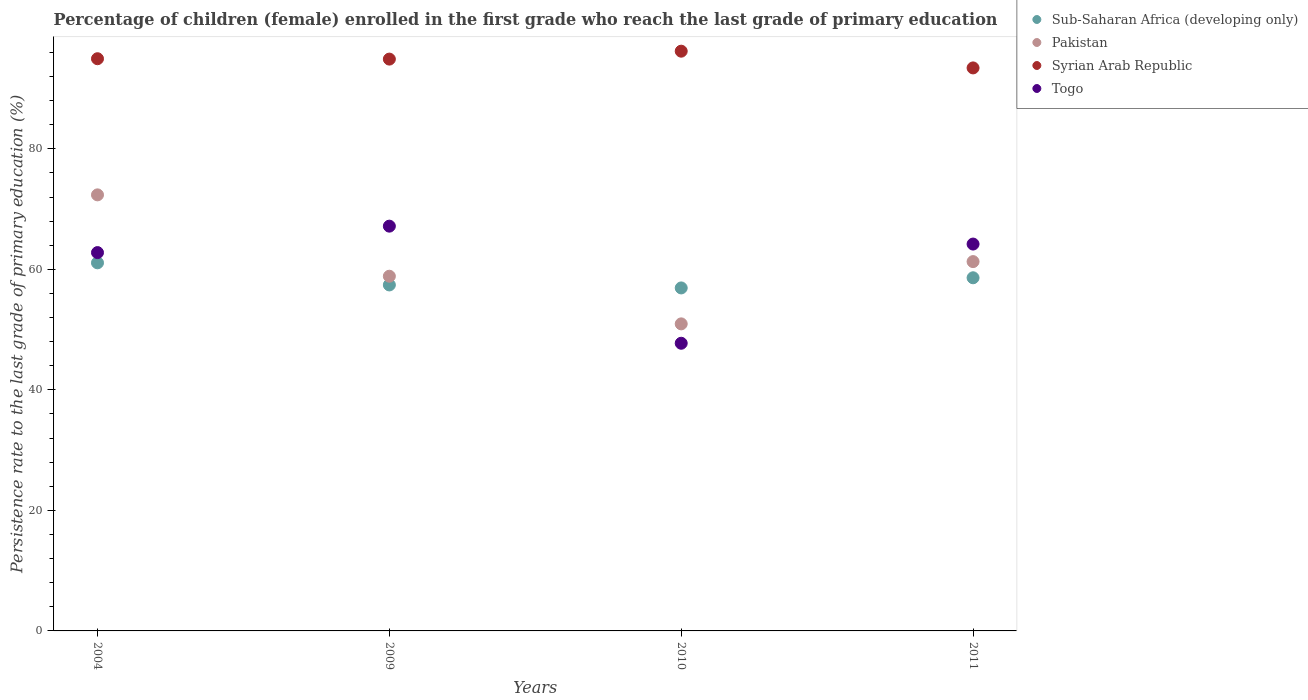How many different coloured dotlines are there?
Ensure brevity in your answer.  4. What is the persistence rate of children in Togo in 2004?
Make the answer very short. 62.78. Across all years, what is the maximum persistence rate of children in Sub-Saharan Africa (developing only)?
Your answer should be very brief. 61.08. Across all years, what is the minimum persistence rate of children in Togo?
Your response must be concise. 47.74. What is the total persistence rate of children in Sub-Saharan Africa (developing only) in the graph?
Provide a short and direct response. 234.02. What is the difference between the persistence rate of children in Syrian Arab Republic in 2009 and that in 2010?
Your answer should be very brief. -1.32. What is the difference between the persistence rate of children in Togo in 2011 and the persistence rate of children in Syrian Arab Republic in 2010?
Your answer should be compact. -32.01. What is the average persistence rate of children in Pakistan per year?
Your answer should be very brief. 60.87. In the year 2004, what is the difference between the persistence rate of children in Pakistan and persistence rate of children in Sub-Saharan Africa (developing only)?
Make the answer very short. 11.28. In how many years, is the persistence rate of children in Sub-Saharan Africa (developing only) greater than 32 %?
Provide a short and direct response. 4. What is the ratio of the persistence rate of children in Syrian Arab Republic in 2004 to that in 2009?
Offer a very short reply. 1. Is the difference between the persistence rate of children in Pakistan in 2004 and 2010 greater than the difference between the persistence rate of children in Sub-Saharan Africa (developing only) in 2004 and 2010?
Provide a succinct answer. Yes. What is the difference between the highest and the second highest persistence rate of children in Sub-Saharan Africa (developing only)?
Offer a very short reply. 2.48. What is the difference between the highest and the lowest persistence rate of children in Pakistan?
Make the answer very short. 21.41. In how many years, is the persistence rate of children in Sub-Saharan Africa (developing only) greater than the average persistence rate of children in Sub-Saharan Africa (developing only) taken over all years?
Offer a very short reply. 2. Is it the case that in every year, the sum of the persistence rate of children in Syrian Arab Republic and persistence rate of children in Togo  is greater than the persistence rate of children in Pakistan?
Give a very brief answer. Yes. Is the persistence rate of children in Togo strictly less than the persistence rate of children in Pakistan over the years?
Your answer should be very brief. No. Are the values on the major ticks of Y-axis written in scientific E-notation?
Ensure brevity in your answer.  No. How many legend labels are there?
Provide a succinct answer. 4. How are the legend labels stacked?
Provide a short and direct response. Vertical. What is the title of the graph?
Provide a short and direct response. Percentage of children (female) enrolled in the first grade who reach the last grade of primary education. Does "Qatar" appear as one of the legend labels in the graph?
Provide a short and direct response. No. What is the label or title of the Y-axis?
Ensure brevity in your answer.  Persistence rate to the last grade of primary education (%). What is the Persistence rate to the last grade of primary education (%) of Sub-Saharan Africa (developing only) in 2004?
Ensure brevity in your answer.  61.08. What is the Persistence rate to the last grade of primary education (%) in Pakistan in 2004?
Provide a short and direct response. 72.36. What is the Persistence rate to the last grade of primary education (%) of Syrian Arab Republic in 2004?
Your answer should be compact. 94.96. What is the Persistence rate to the last grade of primary education (%) of Togo in 2004?
Your response must be concise. 62.78. What is the Persistence rate to the last grade of primary education (%) of Sub-Saharan Africa (developing only) in 2009?
Keep it short and to the point. 57.41. What is the Persistence rate to the last grade of primary education (%) in Pakistan in 2009?
Keep it short and to the point. 58.86. What is the Persistence rate to the last grade of primary education (%) of Syrian Arab Republic in 2009?
Make the answer very short. 94.89. What is the Persistence rate to the last grade of primary education (%) in Togo in 2009?
Ensure brevity in your answer.  67.17. What is the Persistence rate to the last grade of primary education (%) in Sub-Saharan Africa (developing only) in 2010?
Offer a terse response. 56.92. What is the Persistence rate to the last grade of primary education (%) of Pakistan in 2010?
Give a very brief answer. 50.95. What is the Persistence rate to the last grade of primary education (%) in Syrian Arab Republic in 2010?
Your answer should be compact. 96.21. What is the Persistence rate to the last grade of primary education (%) in Togo in 2010?
Your response must be concise. 47.74. What is the Persistence rate to the last grade of primary education (%) in Sub-Saharan Africa (developing only) in 2011?
Provide a short and direct response. 58.6. What is the Persistence rate to the last grade of primary education (%) in Pakistan in 2011?
Offer a very short reply. 61.29. What is the Persistence rate to the last grade of primary education (%) in Syrian Arab Republic in 2011?
Your response must be concise. 93.43. What is the Persistence rate to the last grade of primary education (%) of Togo in 2011?
Provide a short and direct response. 64.2. Across all years, what is the maximum Persistence rate to the last grade of primary education (%) of Sub-Saharan Africa (developing only)?
Ensure brevity in your answer.  61.08. Across all years, what is the maximum Persistence rate to the last grade of primary education (%) in Pakistan?
Offer a terse response. 72.36. Across all years, what is the maximum Persistence rate to the last grade of primary education (%) in Syrian Arab Republic?
Provide a succinct answer. 96.21. Across all years, what is the maximum Persistence rate to the last grade of primary education (%) of Togo?
Give a very brief answer. 67.17. Across all years, what is the minimum Persistence rate to the last grade of primary education (%) of Sub-Saharan Africa (developing only)?
Offer a terse response. 56.92. Across all years, what is the minimum Persistence rate to the last grade of primary education (%) of Pakistan?
Offer a very short reply. 50.95. Across all years, what is the minimum Persistence rate to the last grade of primary education (%) of Syrian Arab Republic?
Make the answer very short. 93.43. Across all years, what is the minimum Persistence rate to the last grade of primary education (%) in Togo?
Your answer should be very brief. 47.74. What is the total Persistence rate to the last grade of primary education (%) of Sub-Saharan Africa (developing only) in the graph?
Provide a short and direct response. 234.02. What is the total Persistence rate to the last grade of primary education (%) of Pakistan in the graph?
Offer a very short reply. 243.47. What is the total Persistence rate to the last grade of primary education (%) of Syrian Arab Republic in the graph?
Your answer should be very brief. 379.48. What is the total Persistence rate to the last grade of primary education (%) of Togo in the graph?
Keep it short and to the point. 241.89. What is the difference between the Persistence rate to the last grade of primary education (%) in Sub-Saharan Africa (developing only) in 2004 and that in 2009?
Offer a very short reply. 3.67. What is the difference between the Persistence rate to the last grade of primary education (%) in Pakistan in 2004 and that in 2009?
Give a very brief answer. 13.5. What is the difference between the Persistence rate to the last grade of primary education (%) in Syrian Arab Republic in 2004 and that in 2009?
Ensure brevity in your answer.  0.06. What is the difference between the Persistence rate to the last grade of primary education (%) of Togo in 2004 and that in 2009?
Ensure brevity in your answer.  -4.39. What is the difference between the Persistence rate to the last grade of primary education (%) in Sub-Saharan Africa (developing only) in 2004 and that in 2010?
Your answer should be very brief. 4.17. What is the difference between the Persistence rate to the last grade of primary education (%) of Pakistan in 2004 and that in 2010?
Keep it short and to the point. 21.41. What is the difference between the Persistence rate to the last grade of primary education (%) in Syrian Arab Republic in 2004 and that in 2010?
Your answer should be compact. -1.25. What is the difference between the Persistence rate to the last grade of primary education (%) of Togo in 2004 and that in 2010?
Provide a succinct answer. 15.05. What is the difference between the Persistence rate to the last grade of primary education (%) of Sub-Saharan Africa (developing only) in 2004 and that in 2011?
Offer a very short reply. 2.48. What is the difference between the Persistence rate to the last grade of primary education (%) in Pakistan in 2004 and that in 2011?
Your answer should be compact. 11.08. What is the difference between the Persistence rate to the last grade of primary education (%) of Syrian Arab Republic in 2004 and that in 2011?
Give a very brief answer. 1.53. What is the difference between the Persistence rate to the last grade of primary education (%) of Togo in 2004 and that in 2011?
Make the answer very short. -1.42. What is the difference between the Persistence rate to the last grade of primary education (%) in Sub-Saharan Africa (developing only) in 2009 and that in 2010?
Offer a very short reply. 0.5. What is the difference between the Persistence rate to the last grade of primary education (%) of Pakistan in 2009 and that in 2010?
Give a very brief answer. 7.91. What is the difference between the Persistence rate to the last grade of primary education (%) in Syrian Arab Republic in 2009 and that in 2010?
Offer a very short reply. -1.32. What is the difference between the Persistence rate to the last grade of primary education (%) of Togo in 2009 and that in 2010?
Provide a succinct answer. 19.43. What is the difference between the Persistence rate to the last grade of primary education (%) of Sub-Saharan Africa (developing only) in 2009 and that in 2011?
Keep it short and to the point. -1.19. What is the difference between the Persistence rate to the last grade of primary education (%) in Pakistan in 2009 and that in 2011?
Your answer should be compact. -2.43. What is the difference between the Persistence rate to the last grade of primary education (%) in Syrian Arab Republic in 2009 and that in 2011?
Ensure brevity in your answer.  1.46. What is the difference between the Persistence rate to the last grade of primary education (%) in Togo in 2009 and that in 2011?
Your response must be concise. 2.97. What is the difference between the Persistence rate to the last grade of primary education (%) of Sub-Saharan Africa (developing only) in 2010 and that in 2011?
Your response must be concise. -1.68. What is the difference between the Persistence rate to the last grade of primary education (%) of Pakistan in 2010 and that in 2011?
Make the answer very short. -10.33. What is the difference between the Persistence rate to the last grade of primary education (%) of Syrian Arab Republic in 2010 and that in 2011?
Provide a succinct answer. 2.78. What is the difference between the Persistence rate to the last grade of primary education (%) in Togo in 2010 and that in 2011?
Your response must be concise. -16.46. What is the difference between the Persistence rate to the last grade of primary education (%) in Sub-Saharan Africa (developing only) in 2004 and the Persistence rate to the last grade of primary education (%) in Pakistan in 2009?
Ensure brevity in your answer.  2.22. What is the difference between the Persistence rate to the last grade of primary education (%) of Sub-Saharan Africa (developing only) in 2004 and the Persistence rate to the last grade of primary education (%) of Syrian Arab Republic in 2009?
Your answer should be compact. -33.81. What is the difference between the Persistence rate to the last grade of primary education (%) in Sub-Saharan Africa (developing only) in 2004 and the Persistence rate to the last grade of primary education (%) in Togo in 2009?
Offer a very short reply. -6.09. What is the difference between the Persistence rate to the last grade of primary education (%) of Pakistan in 2004 and the Persistence rate to the last grade of primary education (%) of Syrian Arab Republic in 2009?
Your answer should be very brief. -22.53. What is the difference between the Persistence rate to the last grade of primary education (%) of Pakistan in 2004 and the Persistence rate to the last grade of primary education (%) of Togo in 2009?
Your answer should be compact. 5.19. What is the difference between the Persistence rate to the last grade of primary education (%) of Syrian Arab Republic in 2004 and the Persistence rate to the last grade of primary education (%) of Togo in 2009?
Your response must be concise. 27.78. What is the difference between the Persistence rate to the last grade of primary education (%) in Sub-Saharan Africa (developing only) in 2004 and the Persistence rate to the last grade of primary education (%) in Pakistan in 2010?
Give a very brief answer. 10.13. What is the difference between the Persistence rate to the last grade of primary education (%) of Sub-Saharan Africa (developing only) in 2004 and the Persistence rate to the last grade of primary education (%) of Syrian Arab Republic in 2010?
Provide a succinct answer. -35.12. What is the difference between the Persistence rate to the last grade of primary education (%) of Sub-Saharan Africa (developing only) in 2004 and the Persistence rate to the last grade of primary education (%) of Togo in 2010?
Provide a succinct answer. 13.35. What is the difference between the Persistence rate to the last grade of primary education (%) in Pakistan in 2004 and the Persistence rate to the last grade of primary education (%) in Syrian Arab Republic in 2010?
Offer a terse response. -23.84. What is the difference between the Persistence rate to the last grade of primary education (%) in Pakistan in 2004 and the Persistence rate to the last grade of primary education (%) in Togo in 2010?
Give a very brief answer. 24.63. What is the difference between the Persistence rate to the last grade of primary education (%) in Syrian Arab Republic in 2004 and the Persistence rate to the last grade of primary education (%) in Togo in 2010?
Offer a very short reply. 47.22. What is the difference between the Persistence rate to the last grade of primary education (%) of Sub-Saharan Africa (developing only) in 2004 and the Persistence rate to the last grade of primary education (%) of Pakistan in 2011?
Provide a succinct answer. -0.2. What is the difference between the Persistence rate to the last grade of primary education (%) of Sub-Saharan Africa (developing only) in 2004 and the Persistence rate to the last grade of primary education (%) of Syrian Arab Republic in 2011?
Make the answer very short. -32.35. What is the difference between the Persistence rate to the last grade of primary education (%) of Sub-Saharan Africa (developing only) in 2004 and the Persistence rate to the last grade of primary education (%) of Togo in 2011?
Keep it short and to the point. -3.11. What is the difference between the Persistence rate to the last grade of primary education (%) of Pakistan in 2004 and the Persistence rate to the last grade of primary education (%) of Syrian Arab Republic in 2011?
Give a very brief answer. -21.07. What is the difference between the Persistence rate to the last grade of primary education (%) in Pakistan in 2004 and the Persistence rate to the last grade of primary education (%) in Togo in 2011?
Offer a terse response. 8.16. What is the difference between the Persistence rate to the last grade of primary education (%) in Syrian Arab Republic in 2004 and the Persistence rate to the last grade of primary education (%) in Togo in 2011?
Give a very brief answer. 30.76. What is the difference between the Persistence rate to the last grade of primary education (%) of Sub-Saharan Africa (developing only) in 2009 and the Persistence rate to the last grade of primary education (%) of Pakistan in 2010?
Your answer should be compact. 6.46. What is the difference between the Persistence rate to the last grade of primary education (%) in Sub-Saharan Africa (developing only) in 2009 and the Persistence rate to the last grade of primary education (%) in Syrian Arab Republic in 2010?
Your answer should be compact. -38.79. What is the difference between the Persistence rate to the last grade of primary education (%) in Sub-Saharan Africa (developing only) in 2009 and the Persistence rate to the last grade of primary education (%) in Togo in 2010?
Offer a very short reply. 9.68. What is the difference between the Persistence rate to the last grade of primary education (%) of Pakistan in 2009 and the Persistence rate to the last grade of primary education (%) of Syrian Arab Republic in 2010?
Provide a succinct answer. -37.35. What is the difference between the Persistence rate to the last grade of primary education (%) of Pakistan in 2009 and the Persistence rate to the last grade of primary education (%) of Togo in 2010?
Provide a succinct answer. 11.12. What is the difference between the Persistence rate to the last grade of primary education (%) of Syrian Arab Republic in 2009 and the Persistence rate to the last grade of primary education (%) of Togo in 2010?
Offer a very short reply. 47.15. What is the difference between the Persistence rate to the last grade of primary education (%) of Sub-Saharan Africa (developing only) in 2009 and the Persistence rate to the last grade of primary education (%) of Pakistan in 2011?
Your response must be concise. -3.87. What is the difference between the Persistence rate to the last grade of primary education (%) in Sub-Saharan Africa (developing only) in 2009 and the Persistence rate to the last grade of primary education (%) in Syrian Arab Republic in 2011?
Offer a very short reply. -36.02. What is the difference between the Persistence rate to the last grade of primary education (%) in Sub-Saharan Africa (developing only) in 2009 and the Persistence rate to the last grade of primary education (%) in Togo in 2011?
Make the answer very short. -6.78. What is the difference between the Persistence rate to the last grade of primary education (%) of Pakistan in 2009 and the Persistence rate to the last grade of primary education (%) of Syrian Arab Republic in 2011?
Make the answer very short. -34.57. What is the difference between the Persistence rate to the last grade of primary education (%) of Pakistan in 2009 and the Persistence rate to the last grade of primary education (%) of Togo in 2011?
Provide a short and direct response. -5.34. What is the difference between the Persistence rate to the last grade of primary education (%) of Syrian Arab Republic in 2009 and the Persistence rate to the last grade of primary education (%) of Togo in 2011?
Provide a short and direct response. 30.69. What is the difference between the Persistence rate to the last grade of primary education (%) in Sub-Saharan Africa (developing only) in 2010 and the Persistence rate to the last grade of primary education (%) in Pakistan in 2011?
Offer a terse response. -4.37. What is the difference between the Persistence rate to the last grade of primary education (%) of Sub-Saharan Africa (developing only) in 2010 and the Persistence rate to the last grade of primary education (%) of Syrian Arab Republic in 2011?
Ensure brevity in your answer.  -36.51. What is the difference between the Persistence rate to the last grade of primary education (%) in Sub-Saharan Africa (developing only) in 2010 and the Persistence rate to the last grade of primary education (%) in Togo in 2011?
Provide a succinct answer. -7.28. What is the difference between the Persistence rate to the last grade of primary education (%) in Pakistan in 2010 and the Persistence rate to the last grade of primary education (%) in Syrian Arab Republic in 2011?
Ensure brevity in your answer.  -42.48. What is the difference between the Persistence rate to the last grade of primary education (%) of Pakistan in 2010 and the Persistence rate to the last grade of primary education (%) of Togo in 2011?
Your response must be concise. -13.24. What is the difference between the Persistence rate to the last grade of primary education (%) of Syrian Arab Republic in 2010 and the Persistence rate to the last grade of primary education (%) of Togo in 2011?
Your answer should be compact. 32.01. What is the average Persistence rate to the last grade of primary education (%) in Sub-Saharan Africa (developing only) per year?
Keep it short and to the point. 58.51. What is the average Persistence rate to the last grade of primary education (%) in Pakistan per year?
Provide a short and direct response. 60.87. What is the average Persistence rate to the last grade of primary education (%) of Syrian Arab Republic per year?
Your answer should be compact. 94.87. What is the average Persistence rate to the last grade of primary education (%) in Togo per year?
Offer a very short reply. 60.47. In the year 2004, what is the difference between the Persistence rate to the last grade of primary education (%) in Sub-Saharan Africa (developing only) and Persistence rate to the last grade of primary education (%) in Pakistan?
Your answer should be compact. -11.28. In the year 2004, what is the difference between the Persistence rate to the last grade of primary education (%) in Sub-Saharan Africa (developing only) and Persistence rate to the last grade of primary education (%) in Syrian Arab Republic?
Keep it short and to the point. -33.87. In the year 2004, what is the difference between the Persistence rate to the last grade of primary education (%) of Sub-Saharan Africa (developing only) and Persistence rate to the last grade of primary education (%) of Togo?
Offer a terse response. -1.7. In the year 2004, what is the difference between the Persistence rate to the last grade of primary education (%) of Pakistan and Persistence rate to the last grade of primary education (%) of Syrian Arab Republic?
Offer a terse response. -22.59. In the year 2004, what is the difference between the Persistence rate to the last grade of primary education (%) of Pakistan and Persistence rate to the last grade of primary education (%) of Togo?
Ensure brevity in your answer.  9.58. In the year 2004, what is the difference between the Persistence rate to the last grade of primary education (%) in Syrian Arab Republic and Persistence rate to the last grade of primary education (%) in Togo?
Your response must be concise. 32.17. In the year 2009, what is the difference between the Persistence rate to the last grade of primary education (%) of Sub-Saharan Africa (developing only) and Persistence rate to the last grade of primary education (%) of Pakistan?
Make the answer very short. -1.45. In the year 2009, what is the difference between the Persistence rate to the last grade of primary education (%) of Sub-Saharan Africa (developing only) and Persistence rate to the last grade of primary education (%) of Syrian Arab Republic?
Keep it short and to the point. -37.48. In the year 2009, what is the difference between the Persistence rate to the last grade of primary education (%) of Sub-Saharan Africa (developing only) and Persistence rate to the last grade of primary education (%) of Togo?
Offer a terse response. -9.76. In the year 2009, what is the difference between the Persistence rate to the last grade of primary education (%) in Pakistan and Persistence rate to the last grade of primary education (%) in Syrian Arab Republic?
Offer a terse response. -36.03. In the year 2009, what is the difference between the Persistence rate to the last grade of primary education (%) of Pakistan and Persistence rate to the last grade of primary education (%) of Togo?
Provide a succinct answer. -8.31. In the year 2009, what is the difference between the Persistence rate to the last grade of primary education (%) in Syrian Arab Republic and Persistence rate to the last grade of primary education (%) in Togo?
Give a very brief answer. 27.72. In the year 2010, what is the difference between the Persistence rate to the last grade of primary education (%) of Sub-Saharan Africa (developing only) and Persistence rate to the last grade of primary education (%) of Pakistan?
Give a very brief answer. 5.96. In the year 2010, what is the difference between the Persistence rate to the last grade of primary education (%) of Sub-Saharan Africa (developing only) and Persistence rate to the last grade of primary education (%) of Syrian Arab Republic?
Give a very brief answer. -39.29. In the year 2010, what is the difference between the Persistence rate to the last grade of primary education (%) in Sub-Saharan Africa (developing only) and Persistence rate to the last grade of primary education (%) in Togo?
Offer a terse response. 9.18. In the year 2010, what is the difference between the Persistence rate to the last grade of primary education (%) in Pakistan and Persistence rate to the last grade of primary education (%) in Syrian Arab Republic?
Offer a terse response. -45.25. In the year 2010, what is the difference between the Persistence rate to the last grade of primary education (%) in Pakistan and Persistence rate to the last grade of primary education (%) in Togo?
Your answer should be very brief. 3.22. In the year 2010, what is the difference between the Persistence rate to the last grade of primary education (%) of Syrian Arab Republic and Persistence rate to the last grade of primary education (%) of Togo?
Your answer should be very brief. 48.47. In the year 2011, what is the difference between the Persistence rate to the last grade of primary education (%) of Sub-Saharan Africa (developing only) and Persistence rate to the last grade of primary education (%) of Pakistan?
Your answer should be very brief. -2.68. In the year 2011, what is the difference between the Persistence rate to the last grade of primary education (%) of Sub-Saharan Africa (developing only) and Persistence rate to the last grade of primary education (%) of Syrian Arab Republic?
Give a very brief answer. -34.83. In the year 2011, what is the difference between the Persistence rate to the last grade of primary education (%) in Sub-Saharan Africa (developing only) and Persistence rate to the last grade of primary education (%) in Togo?
Offer a very short reply. -5.6. In the year 2011, what is the difference between the Persistence rate to the last grade of primary education (%) of Pakistan and Persistence rate to the last grade of primary education (%) of Syrian Arab Republic?
Provide a succinct answer. -32.14. In the year 2011, what is the difference between the Persistence rate to the last grade of primary education (%) in Pakistan and Persistence rate to the last grade of primary education (%) in Togo?
Offer a very short reply. -2.91. In the year 2011, what is the difference between the Persistence rate to the last grade of primary education (%) of Syrian Arab Republic and Persistence rate to the last grade of primary education (%) of Togo?
Provide a succinct answer. 29.23. What is the ratio of the Persistence rate to the last grade of primary education (%) in Sub-Saharan Africa (developing only) in 2004 to that in 2009?
Make the answer very short. 1.06. What is the ratio of the Persistence rate to the last grade of primary education (%) of Pakistan in 2004 to that in 2009?
Provide a short and direct response. 1.23. What is the ratio of the Persistence rate to the last grade of primary education (%) of Togo in 2004 to that in 2009?
Offer a very short reply. 0.93. What is the ratio of the Persistence rate to the last grade of primary education (%) of Sub-Saharan Africa (developing only) in 2004 to that in 2010?
Provide a short and direct response. 1.07. What is the ratio of the Persistence rate to the last grade of primary education (%) of Pakistan in 2004 to that in 2010?
Ensure brevity in your answer.  1.42. What is the ratio of the Persistence rate to the last grade of primary education (%) in Syrian Arab Republic in 2004 to that in 2010?
Make the answer very short. 0.99. What is the ratio of the Persistence rate to the last grade of primary education (%) of Togo in 2004 to that in 2010?
Keep it short and to the point. 1.32. What is the ratio of the Persistence rate to the last grade of primary education (%) in Sub-Saharan Africa (developing only) in 2004 to that in 2011?
Keep it short and to the point. 1.04. What is the ratio of the Persistence rate to the last grade of primary education (%) in Pakistan in 2004 to that in 2011?
Keep it short and to the point. 1.18. What is the ratio of the Persistence rate to the last grade of primary education (%) in Syrian Arab Republic in 2004 to that in 2011?
Your answer should be compact. 1.02. What is the ratio of the Persistence rate to the last grade of primary education (%) in Togo in 2004 to that in 2011?
Offer a very short reply. 0.98. What is the ratio of the Persistence rate to the last grade of primary education (%) in Sub-Saharan Africa (developing only) in 2009 to that in 2010?
Offer a terse response. 1.01. What is the ratio of the Persistence rate to the last grade of primary education (%) in Pakistan in 2009 to that in 2010?
Offer a very short reply. 1.16. What is the ratio of the Persistence rate to the last grade of primary education (%) in Syrian Arab Republic in 2009 to that in 2010?
Offer a very short reply. 0.99. What is the ratio of the Persistence rate to the last grade of primary education (%) in Togo in 2009 to that in 2010?
Your answer should be very brief. 1.41. What is the ratio of the Persistence rate to the last grade of primary education (%) in Sub-Saharan Africa (developing only) in 2009 to that in 2011?
Keep it short and to the point. 0.98. What is the ratio of the Persistence rate to the last grade of primary education (%) in Pakistan in 2009 to that in 2011?
Keep it short and to the point. 0.96. What is the ratio of the Persistence rate to the last grade of primary education (%) in Syrian Arab Republic in 2009 to that in 2011?
Keep it short and to the point. 1.02. What is the ratio of the Persistence rate to the last grade of primary education (%) in Togo in 2009 to that in 2011?
Your response must be concise. 1.05. What is the ratio of the Persistence rate to the last grade of primary education (%) in Sub-Saharan Africa (developing only) in 2010 to that in 2011?
Your answer should be very brief. 0.97. What is the ratio of the Persistence rate to the last grade of primary education (%) of Pakistan in 2010 to that in 2011?
Keep it short and to the point. 0.83. What is the ratio of the Persistence rate to the last grade of primary education (%) of Syrian Arab Republic in 2010 to that in 2011?
Offer a very short reply. 1.03. What is the ratio of the Persistence rate to the last grade of primary education (%) of Togo in 2010 to that in 2011?
Ensure brevity in your answer.  0.74. What is the difference between the highest and the second highest Persistence rate to the last grade of primary education (%) of Sub-Saharan Africa (developing only)?
Your response must be concise. 2.48. What is the difference between the highest and the second highest Persistence rate to the last grade of primary education (%) of Pakistan?
Provide a succinct answer. 11.08. What is the difference between the highest and the second highest Persistence rate to the last grade of primary education (%) in Syrian Arab Republic?
Offer a terse response. 1.25. What is the difference between the highest and the second highest Persistence rate to the last grade of primary education (%) of Togo?
Offer a very short reply. 2.97. What is the difference between the highest and the lowest Persistence rate to the last grade of primary education (%) of Sub-Saharan Africa (developing only)?
Your answer should be compact. 4.17. What is the difference between the highest and the lowest Persistence rate to the last grade of primary education (%) of Pakistan?
Your response must be concise. 21.41. What is the difference between the highest and the lowest Persistence rate to the last grade of primary education (%) in Syrian Arab Republic?
Your answer should be very brief. 2.78. What is the difference between the highest and the lowest Persistence rate to the last grade of primary education (%) in Togo?
Give a very brief answer. 19.43. 